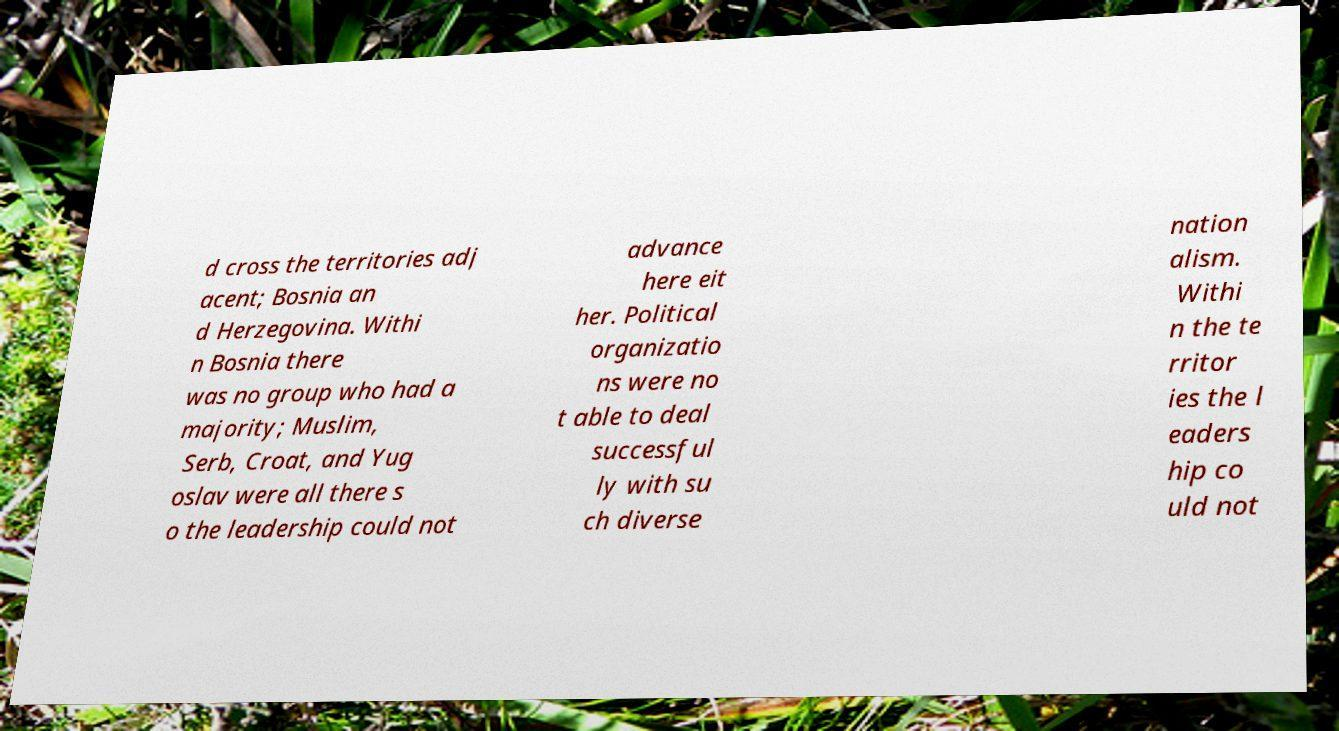Could you extract and type out the text from this image? d cross the territories adj acent; Bosnia an d Herzegovina. Withi n Bosnia there was no group who had a majority; Muslim, Serb, Croat, and Yug oslav were all there s o the leadership could not advance here eit her. Political organizatio ns were no t able to deal successful ly with su ch diverse nation alism. Withi n the te rritor ies the l eaders hip co uld not 